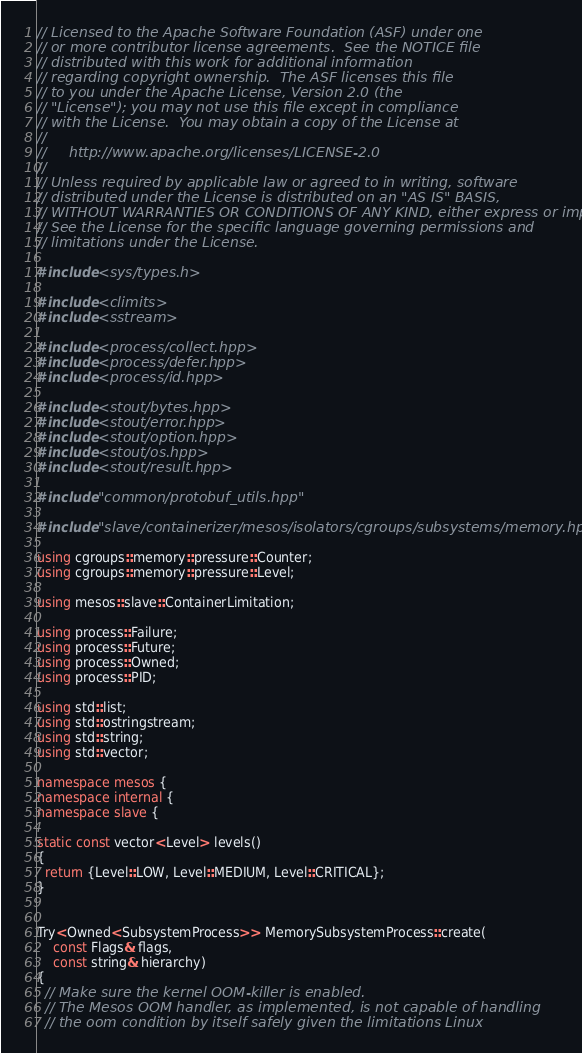Convert code to text. <code><loc_0><loc_0><loc_500><loc_500><_C++_>// Licensed to the Apache Software Foundation (ASF) under one
// or more contributor license agreements.  See the NOTICE file
// distributed with this work for additional information
// regarding copyright ownership.  The ASF licenses this file
// to you under the Apache License, Version 2.0 (the
// "License"); you may not use this file except in compliance
// with the License.  You may obtain a copy of the License at
//
//     http://www.apache.org/licenses/LICENSE-2.0
//
// Unless required by applicable law or agreed to in writing, software
// distributed under the License is distributed on an "AS IS" BASIS,
// WITHOUT WARRANTIES OR CONDITIONS OF ANY KIND, either express or implied.
// See the License for the specific language governing permissions and
// limitations under the License.

#include <sys/types.h>

#include <climits>
#include <sstream>

#include <process/collect.hpp>
#include <process/defer.hpp>
#include <process/id.hpp>

#include <stout/bytes.hpp>
#include <stout/error.hpp>
#include <stout/option.hpp>
#include <stout/os.hpp>
#include <stout/result.hpp>

#include "common/protobuf_utils.hpp"

#include "slave/containerizer/mesos/isolators/cgroups/subsystems/memory.hpp"

using cgroups::memory::pressure::Counter;
using cgroups::memory::pressure::Level;

using mesos::slave::ContainerLimitation;

using process::Failure;
using process::Future;
using process::Owned;
using process::PID;

using std::list;
using std::ostringstream;
using std::string;
using std::vector;

namespace mesos {
namespace internal {
namespace slave {

static const vector<Level> levels()
{
  return {Level::LOW, Level::MEDIUM, Level::CRITICAL};
}


Try<Owned<SubsystemProcess>> MemorySubsystemProcess::create(
    const Flags& flags,
    const string& hierarchy)
{
  // Make sure the kernel OOM-killer is enabled.
  // The Mesos OOM handler, as implemented, is not capable of handling
  // the oom condition by itself safely given the limitations Linux</code> 